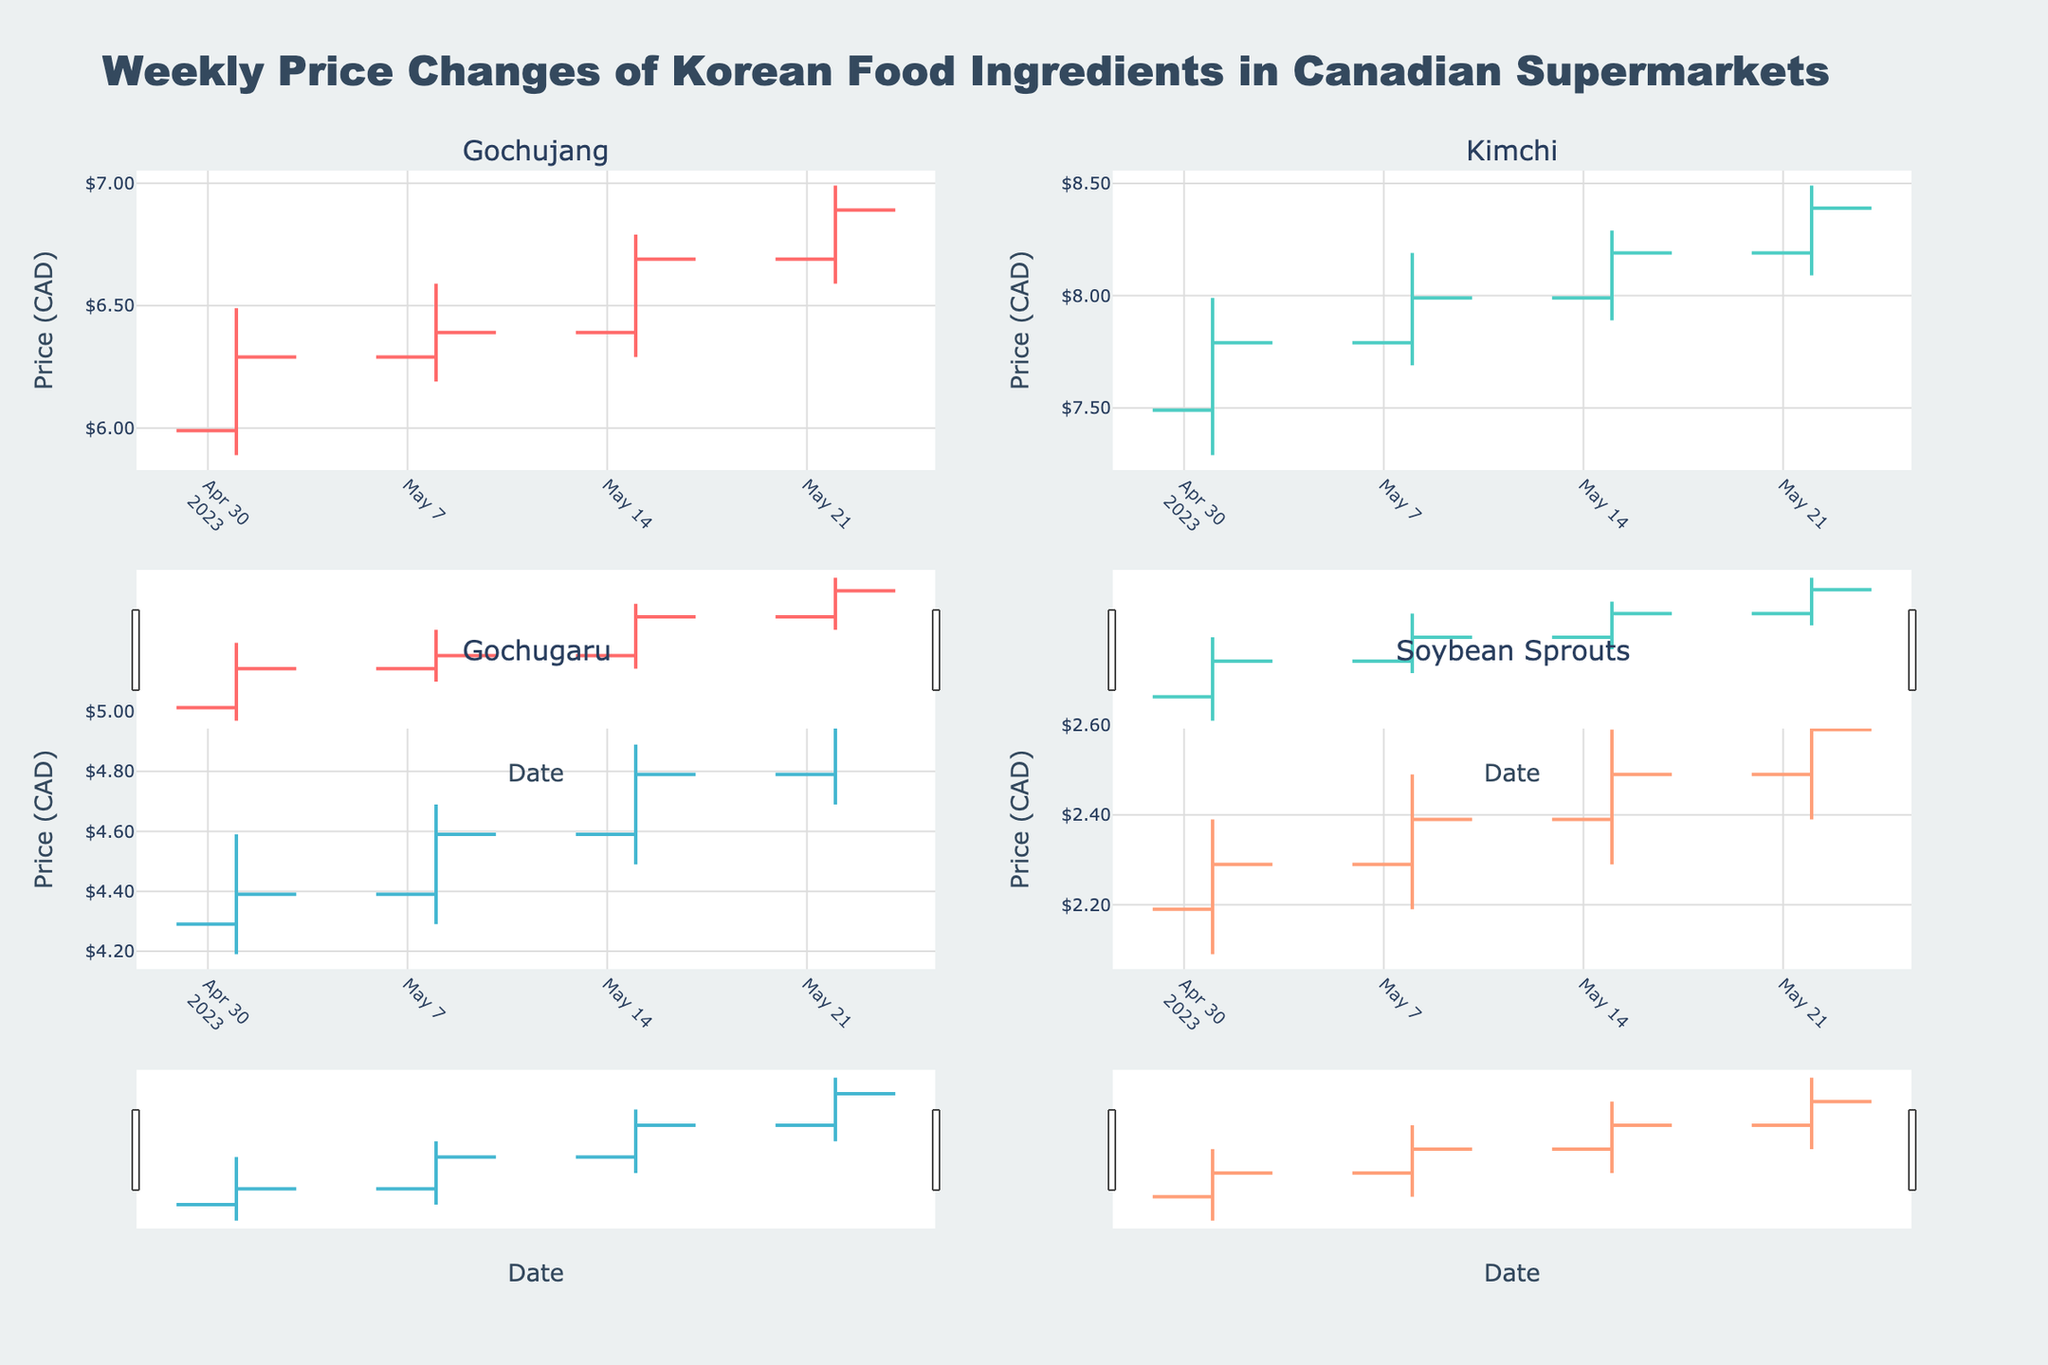Which ingredient had the highest price spike during May? To find the highest price spike, look for the ingredient with the largest difference between high and low values in any week. Gochujang experienced the highest price spike of $0.50 (6.99 - 6.49) during the week of May 22.
Answer: Gochujang What was the close price for Kimchi on May 15? Refer to the "Kimchi" subplot and look for the closing price on the date May 15. The close price is 8.19 CAD.
Answer: 8.19 CAD How did the price of Soybean Sprouts change from May 1 to May 22? Compare the open price on May 1 (2.19 CAD) with the close price on May 22 (2.59 CAD) in the Soybean Sprouts subplot. The price increased by 0.40 CAD.
Answer: Increased by 0.40 CAD Which ingredient showed the most consistent increase in its closing price over the weeks? Identify the ingredient with a consistently increasing closing price each week. Soybean Sprouts showed a consistent increase from 2.29 CAD to 2.39 CAD to 2.49 CAD to 2.59 CAD over the four weeks.
Answer: Soybean Sprouts What were the high prices for Gochugaru each week? Look at the high prices for Gochugaru on each date (05/01, 05/08, 05/15, 05/22). They are 4.59, 4.69, 4.89, and 5.09 CAD respectively.
Answer: 4.59, 4.69, 4.89, 5.09 CAD Which week did Kimchi experience the smallest range between high and low prices? Calculate the range for each week and identify the smallest range. For Kimchi: May 1 (0.70), May 8 (0.50), May 15 (0.40), May 22 (0.40). May 15 and May 22 both have the smallest range of 0.40 CAD.
Answer: Week of May 15 or May 22 What is the average closing price of Gochujang across the given dates? Compute the average of Gochujang's closing prices. The prices are 6.29, 6.39, 6.69, and 6.89. Average = (6.29 + 6.39 + 6.69 + 6.89) / 4 = 6.565 CAD.
Answer: 6.565 CAD Between May 1 and May 22, which ingredient showed the least variation in prices? Find the ingredient with the smallest overall range (high - low) over the entire period. Soybean Sprouts has variations of 0.30, 0.30, 0.30, 0.30. Total = 1.20 CAD variation. Soybean Sprouts showed the least variation.
Answer: Soybean Sprouts 